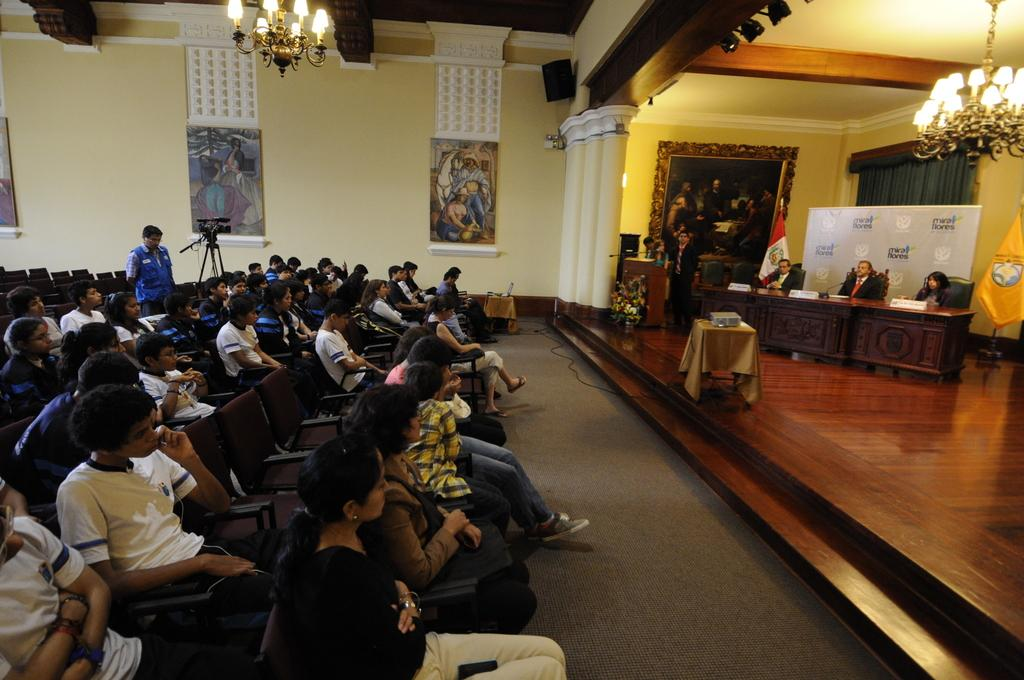What are the people in the image doing? The people in the image are sitting. What are they sitting on? Some people are sitting on chairs, while others are sitting on a wall. What can be seen hanging from the ceiling in the image? There is a chandelier in the image. What decorative elements are present in the image? There are banners and photo frames in the image. What device is used to capture the scene in the image? There is a camera in the image. What type of body is visible in the image? There is no body present in the image; it features people sitting on chairs and a wall. Is there any indication of a war or conflict in the image? No, there is no indication of a war or conflict in the image. 